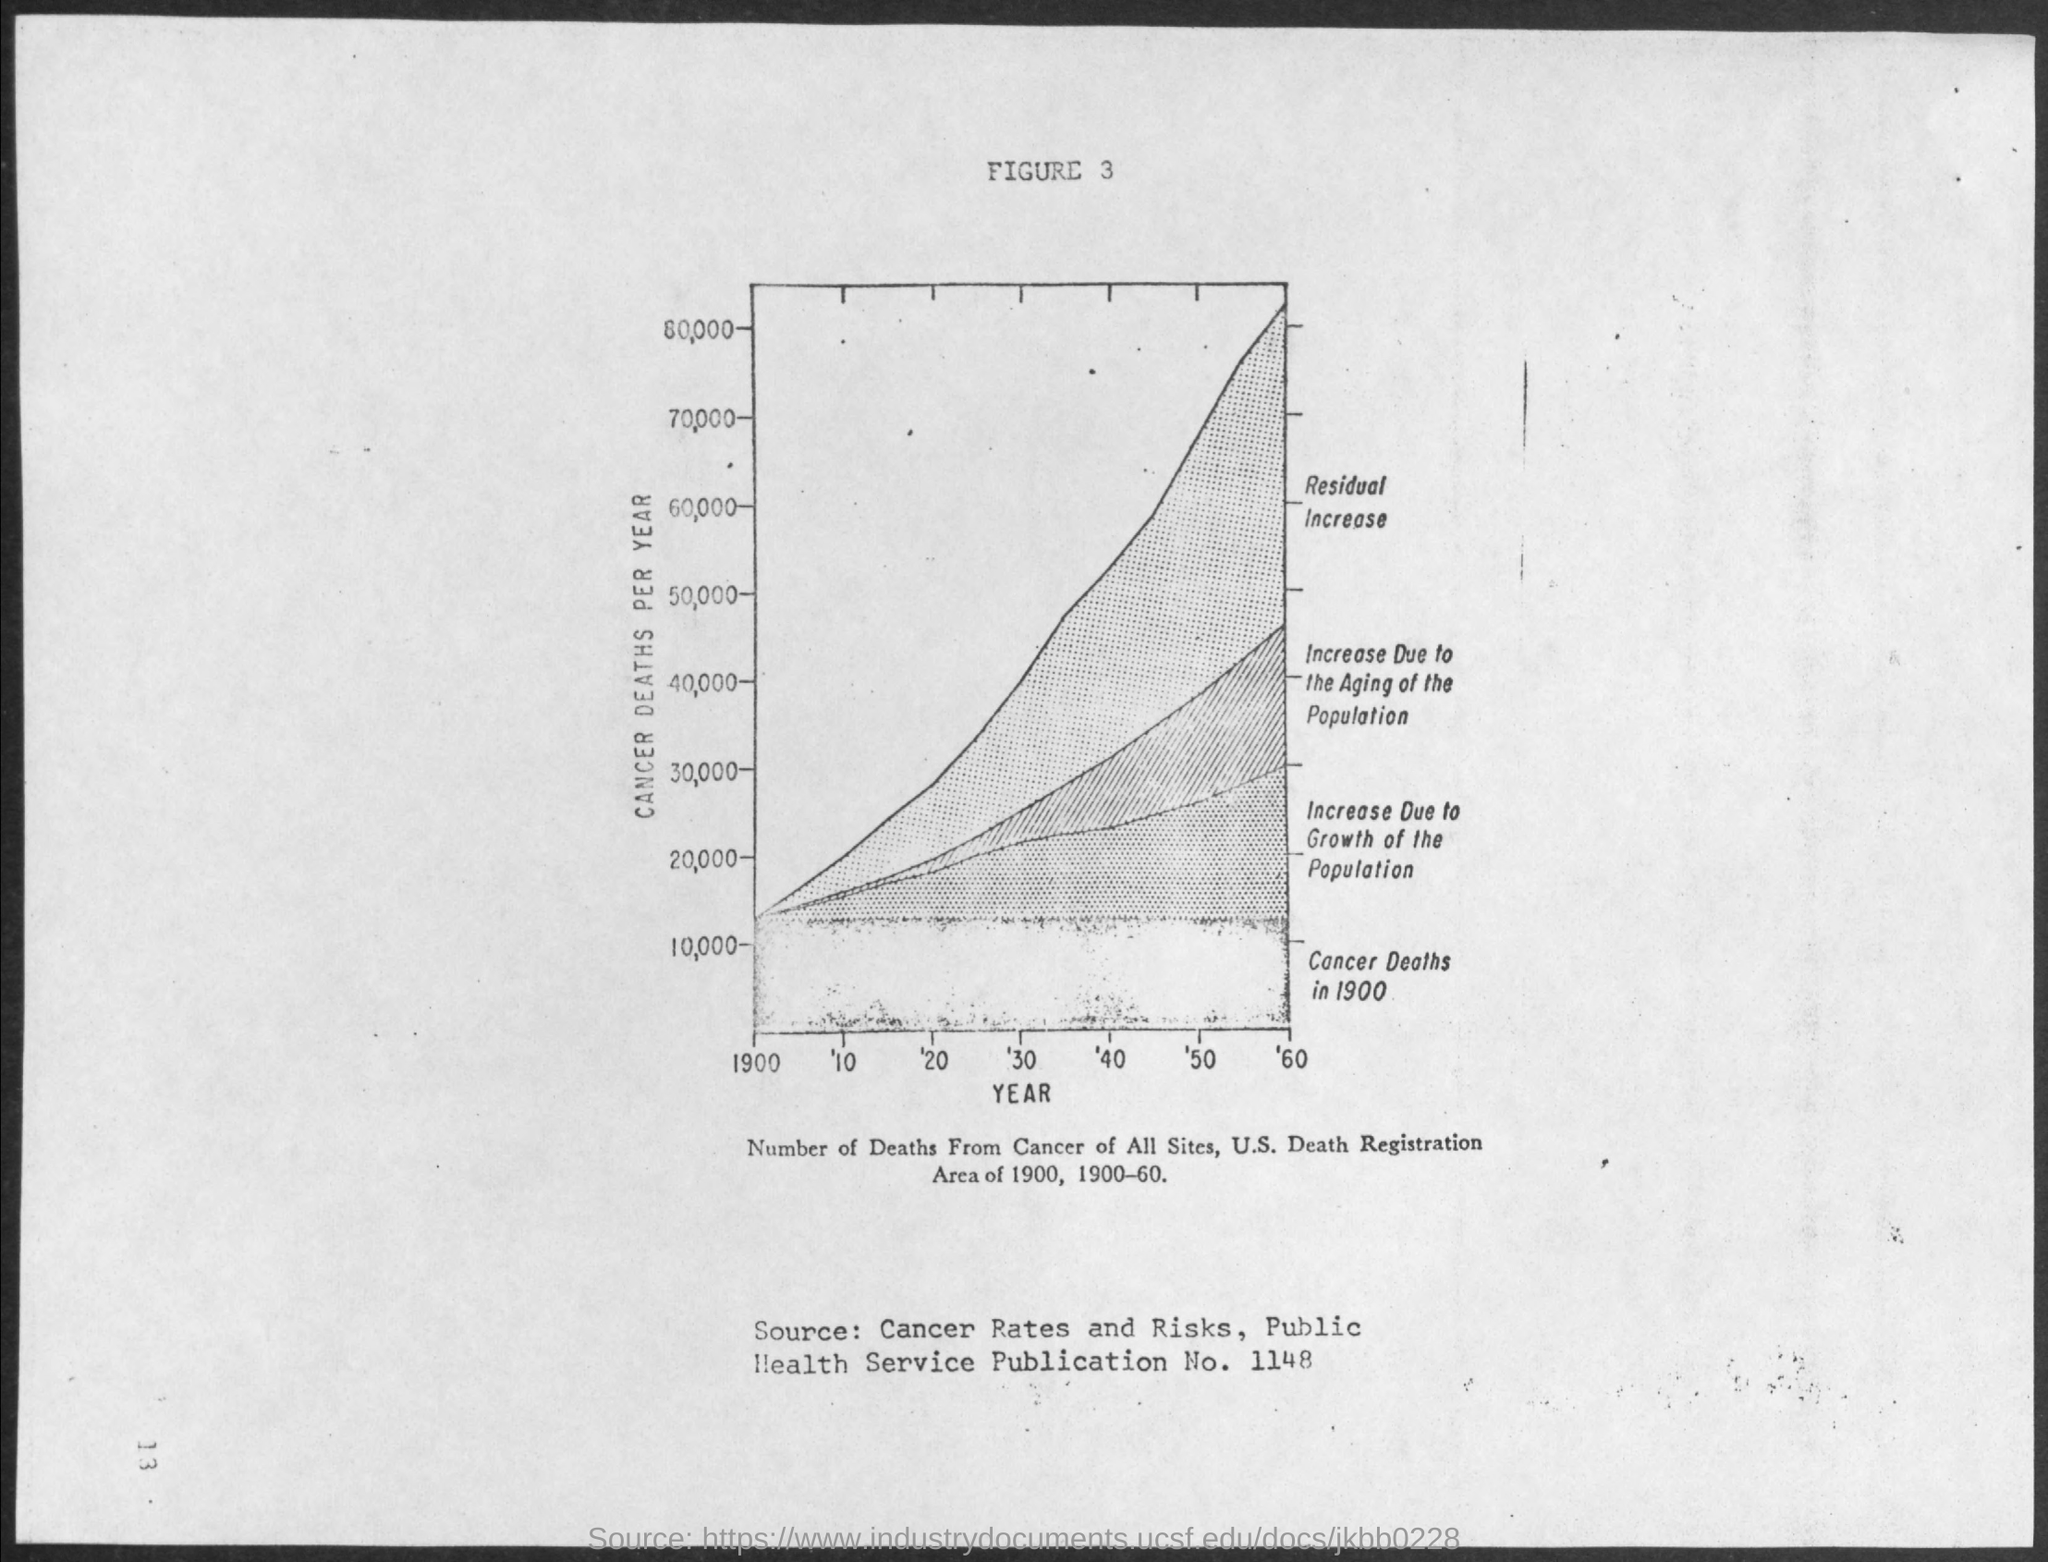What is plotted in the x-axis ?
Make the answer very short. YEAR. What is plotted in the y-axis?
Give a very brief answer. Cancer deaths per year. 